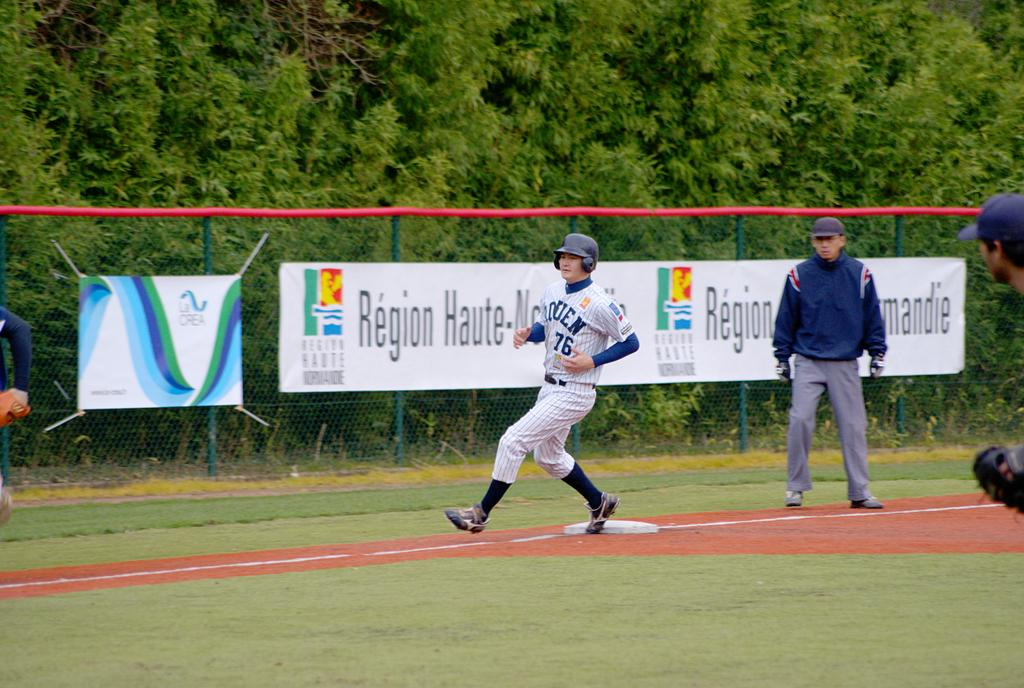<image>
Present a compact description of the photo's key features. Player number 76 in white crosses third base in a baseball game. 